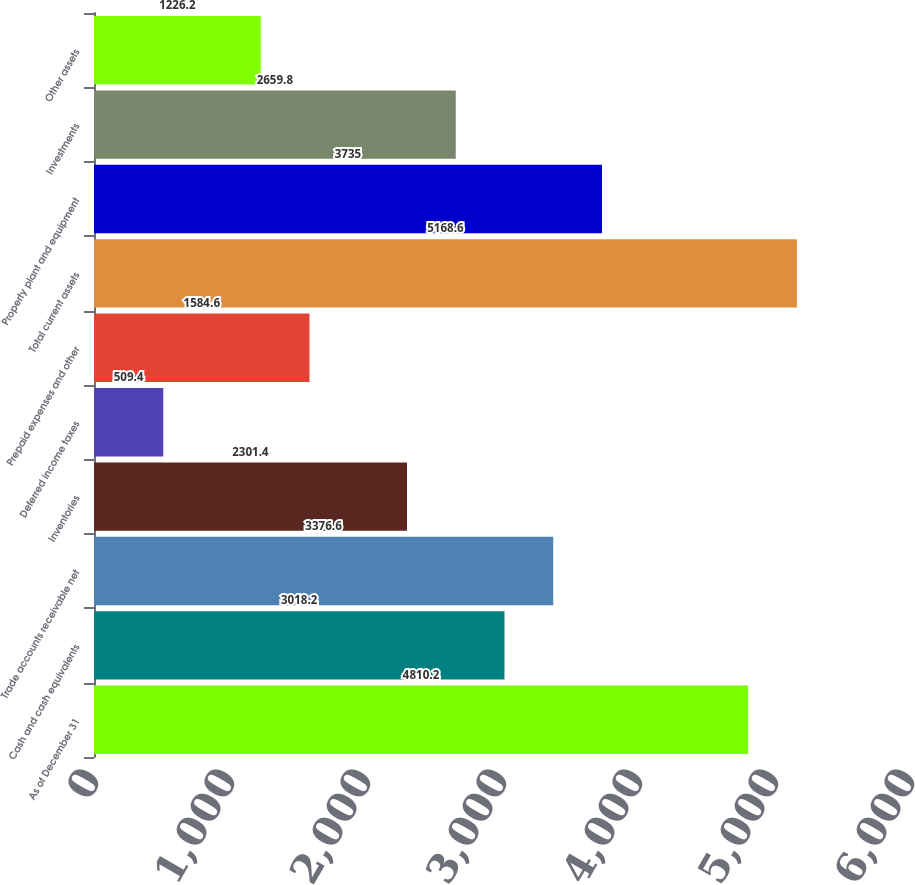Convert chart to OTSL. <chart><loc_0><loc_0><loc_500><loc_500><bar_chart><fcel>As of December 31<fcel>Cash and cash equivalents<fcel>Trade accounts receivable net<fcel>Inventories<fcel>Deferred income taxes<fcel>Prepaid expenses and other<fcel>Total current assets<fcel>Property plant and equipment<fcel>Investments<fcel>Other assets<nl><fcel>4810.2<fcel>3018.2<fcel>3376.6<fcel>2301.4<fcel>509.4<fcel>1584.6<fcel>5168.6<fcel>3735<fcel>2659.8<fcel>1226.2<nl></chart> 